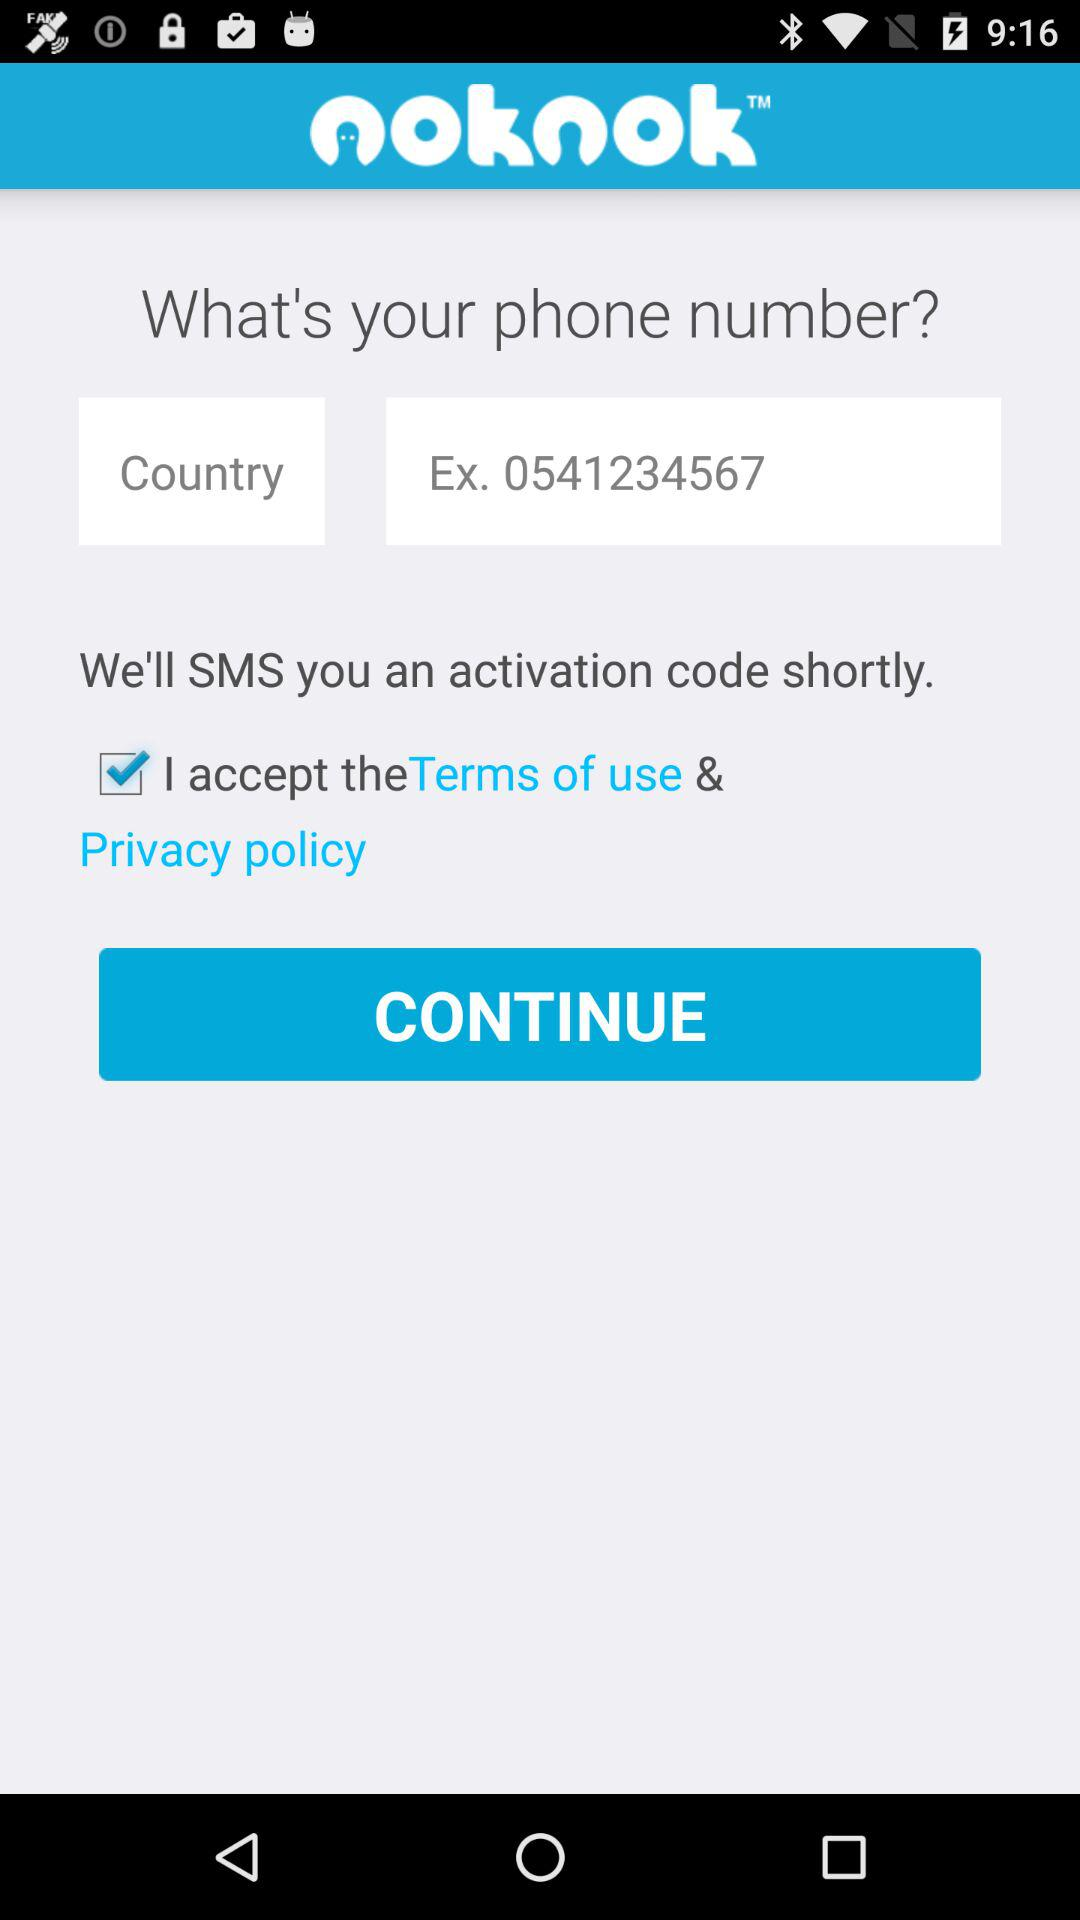What is the status of the option that includes agreement to the “Terms of use” and “Privacy policy”? The status of the option that includes agreement to the "Terms of use" and "Privacy policy" is "on". 